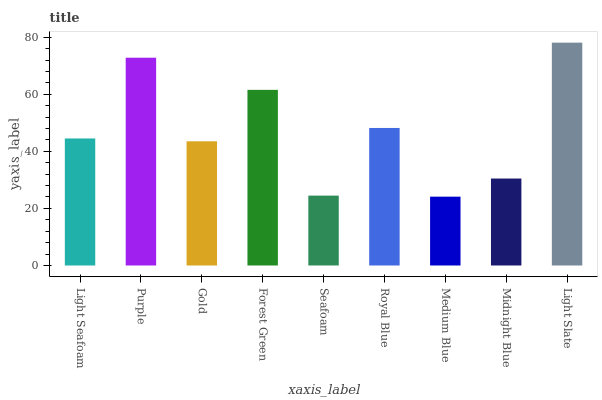Is Medium Blue the minimum?
Answer yes or no. Yes. Is Light Slate the maximum?
Answer yes or no. Yes. Is Purple the minimum?
Answer yes or no. No. Is Purple the maximum?
Answer yes or no. No. Is Purple greater than Light Seafoam?
Answer yes or no. Yes. Is Light Seafoam less than Purple?
Answer yes or no. Yes. Is Light Seafoam greater than Purple?
Answer yes or no. No. Is Purple less than Light Seafoam?
Answer yes or no. No. Is Light Seafoam the high median?
Answer yes or no. Yes. Is Light Seafoam the low median?
Answer yes or no. Yes. Is Purple the high median?
Answer yes or no. No. Is Royal Blue the low median?
Answer yes or no. No. 